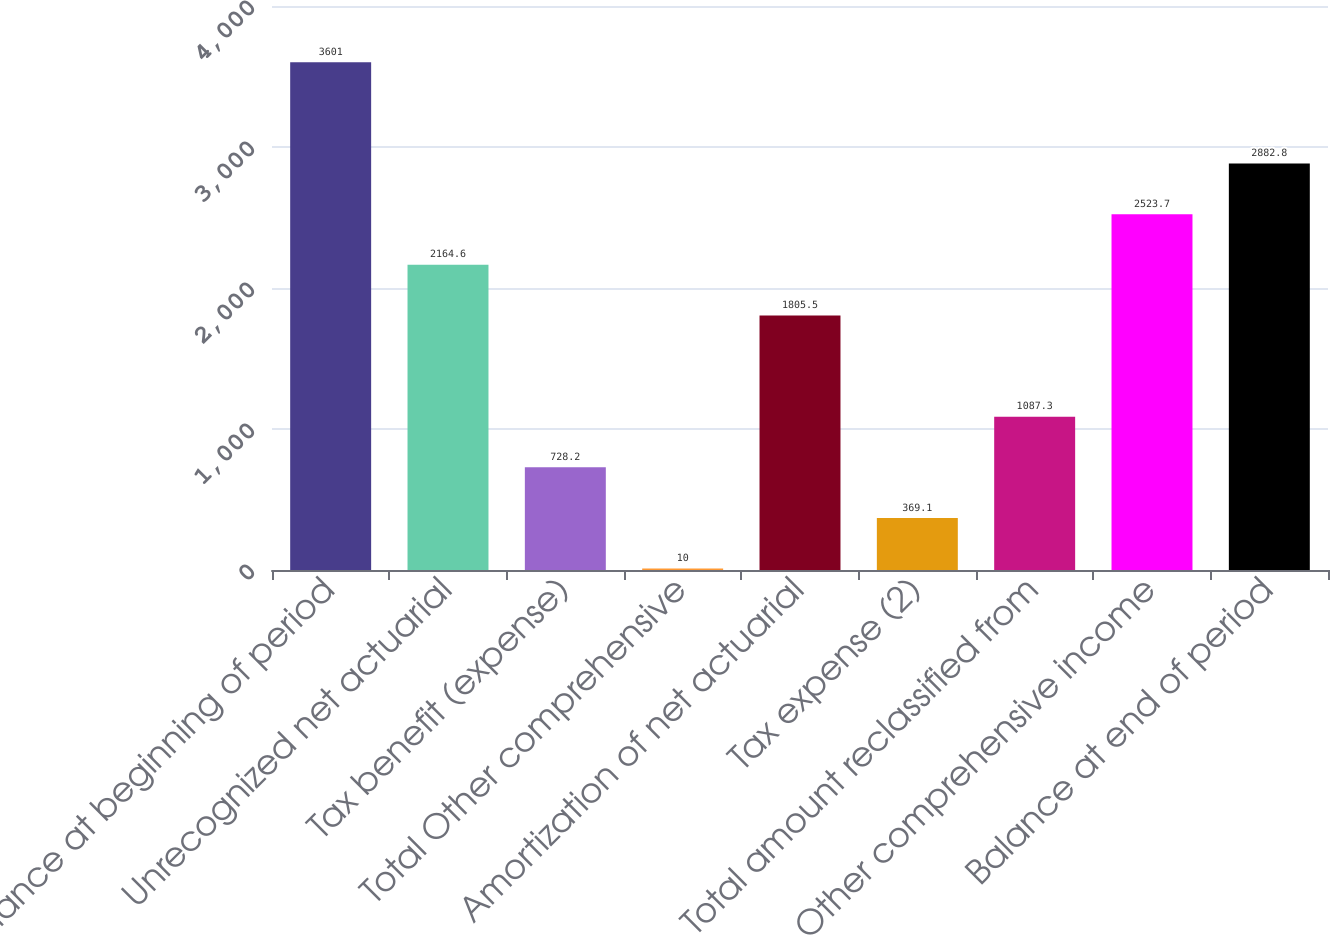<chart> <loc_0><loc_0><loc_500><loc_500><bar_chart><fcel>Balance at beginning of period<fcel>Unrecognized net actuarial<fcel>Tax benefit (expense)<fcel>Total Other comprehensive<fcel>Amortization of net actuarial<fcel>Tax expense (2)<fcel>Total amount reclassified from<fcel>Other comprehensive income<fcel>Balance at end of period<nl><fcel>3601<fcel>2164.6<fcel>728.2<fcel>10<fcel>1805.5<fcel>369.1<fcel>1087.3<fcel>2523.7<fcel>2882.8<nl></chart> 